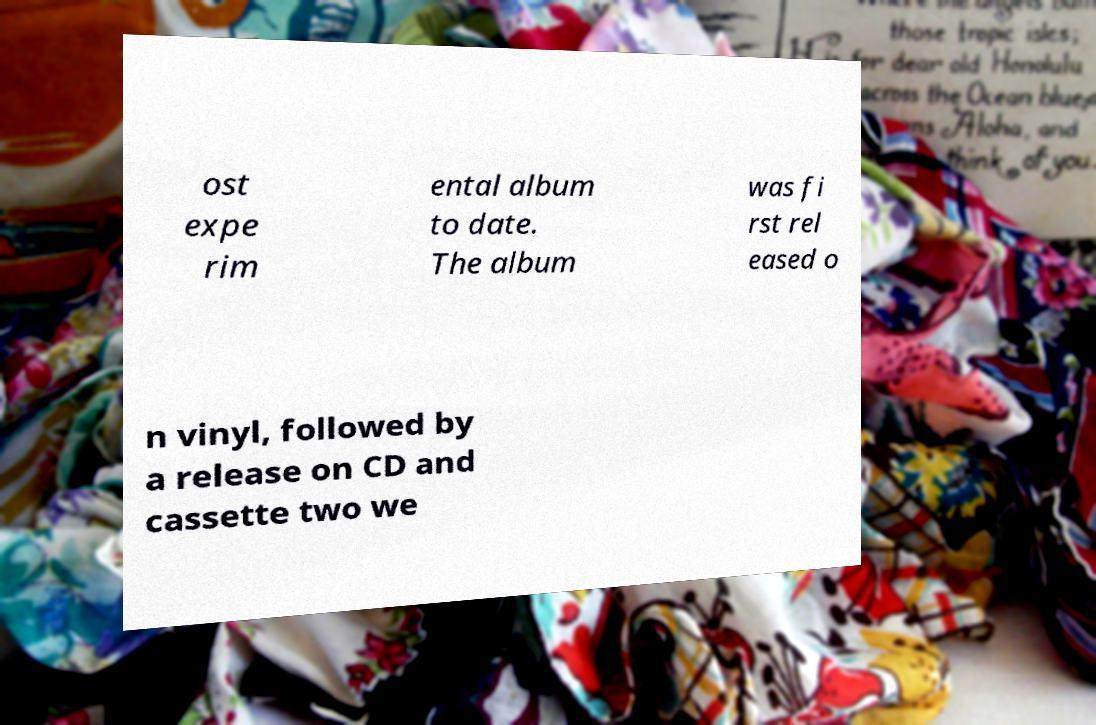Could you extract and type out the text from this image? ost expe rim ental album to date. The album was fi rst rel eased o n vinyl, followed by a release on CD and cassette two we 